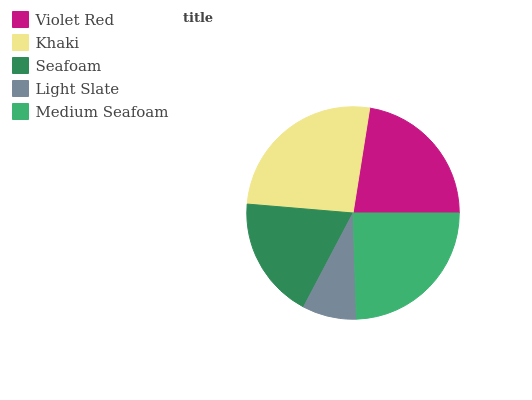Is Light Slate the minimum?
Answer yes or no. Yes. Is Khaki the maximum?
Answer yes or no. Yes. Is Seafoam the minimum?
Answer yes or no. No. Is Seafoam the maximum?
Answer yes or no. No. Is Khaki greater than Seafoam?
Answer yes or no. Yes. Is Seafoam less than Khaki?
Answer yes or no. Yes. Is Seafoam greater than Khaki?
Answer yes or no. No. Is Khaki less than Seafoam?
Answer yes or no. No. Is Violet Red the high median?
Answer yes or no. Yes. Is Violet Red the low median?
Answer yes or no. Yes. Is Seafoam the high median?
Answer yes or no. No. Is Light Slate the low median?
Answer yes or no. No. 